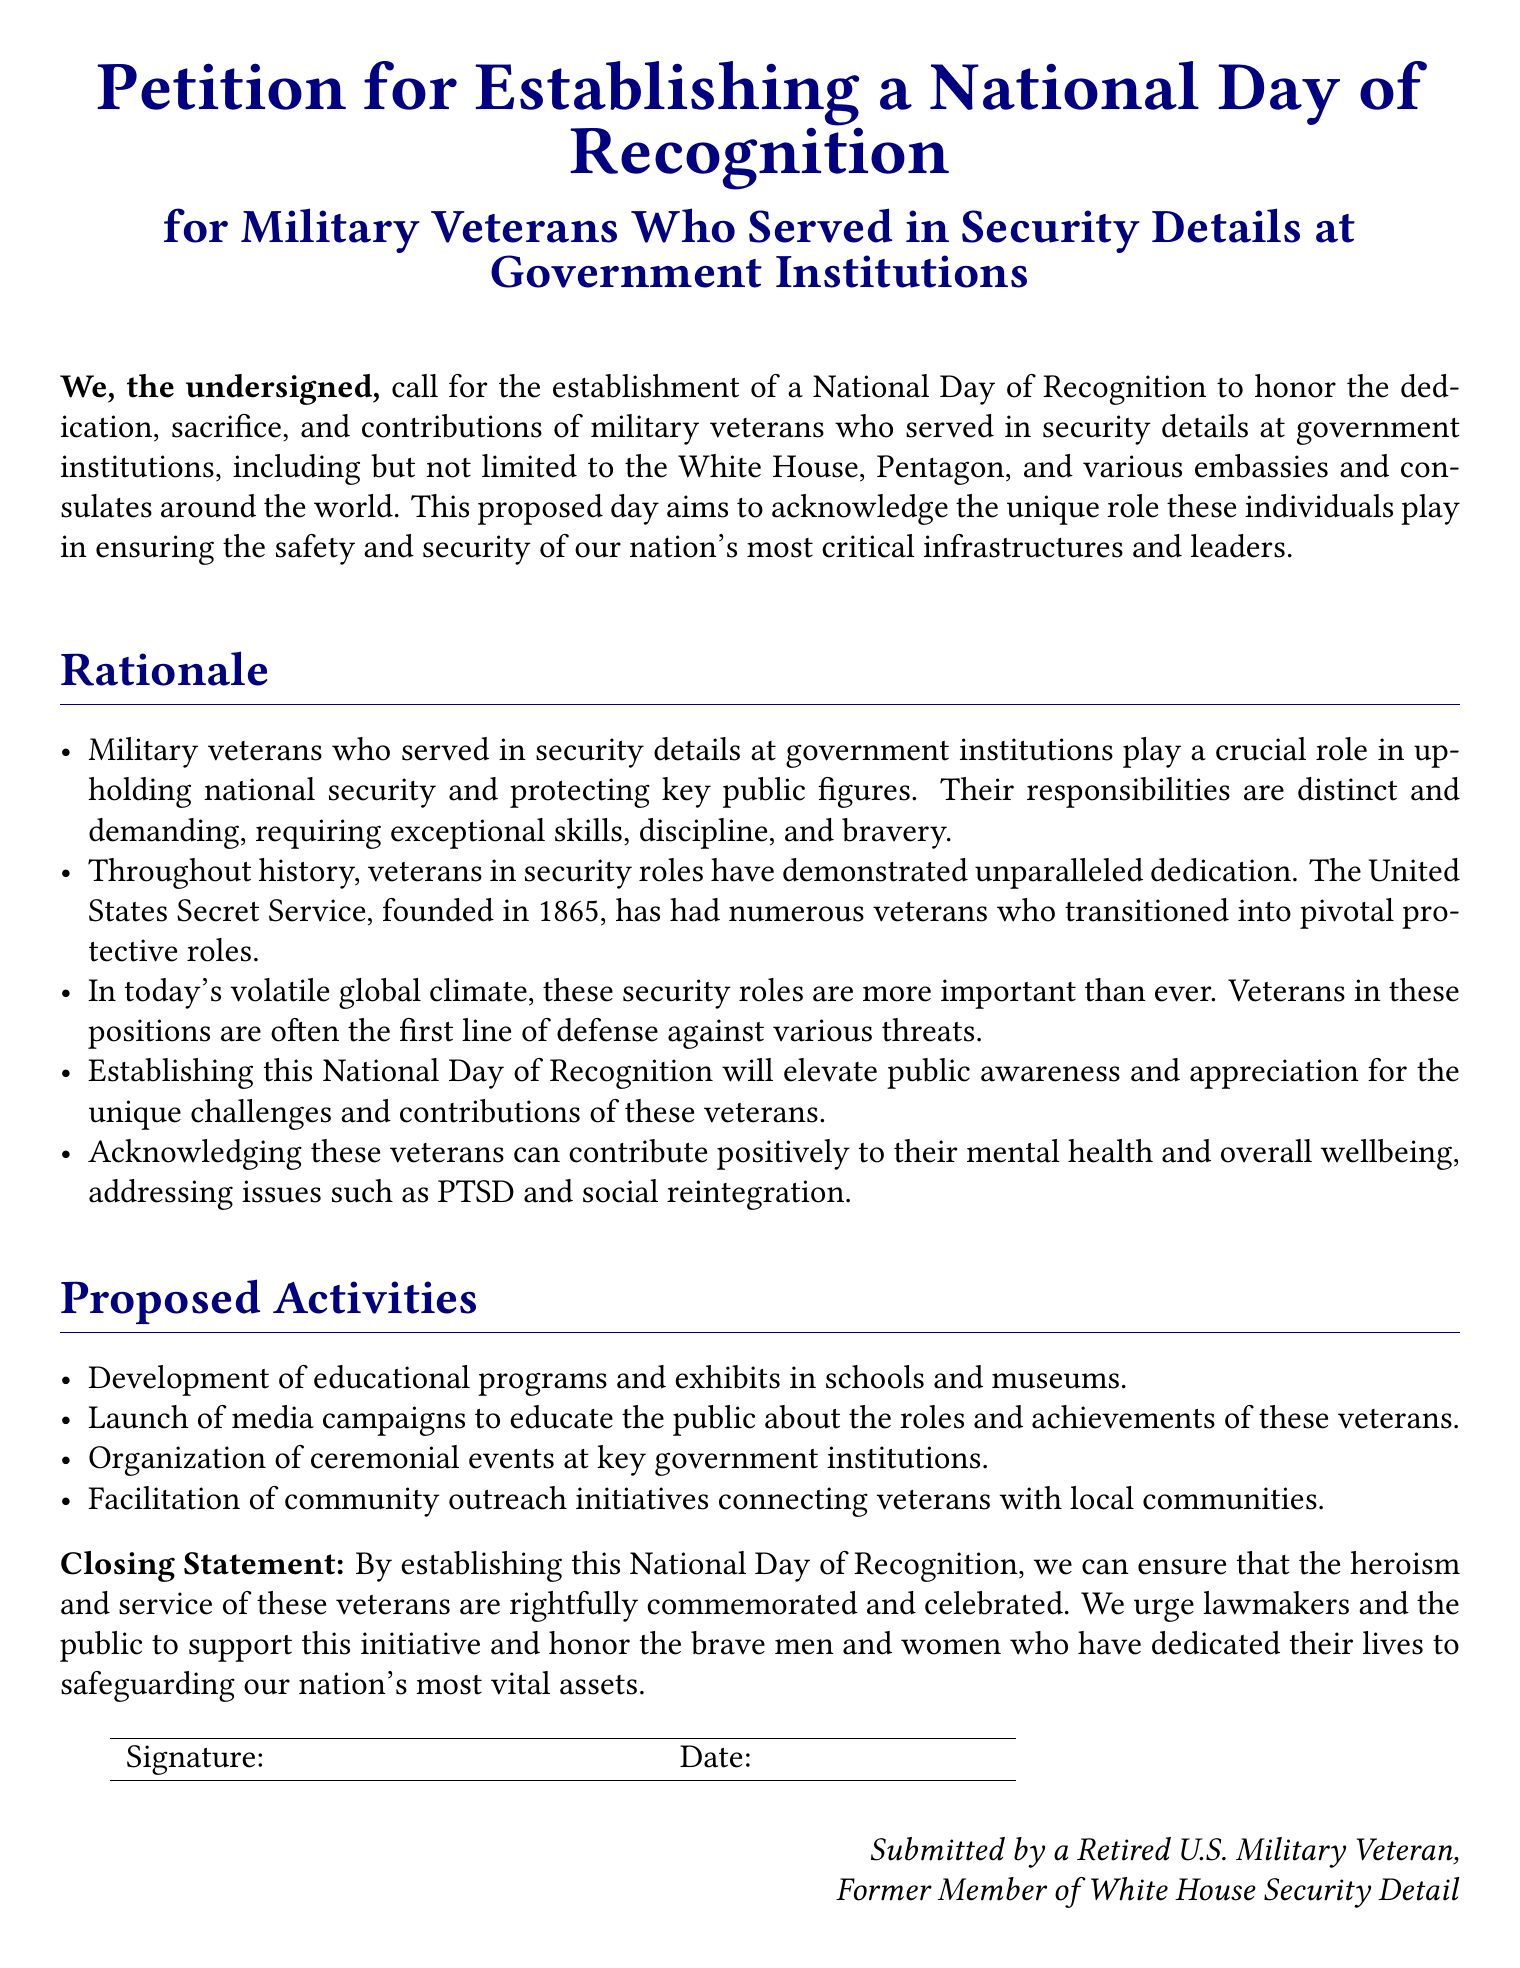What is the purpose of the petition? The purpose of the petition is to call for the establishment of a National Day of Recognition for military veterans who served in security details at government institutions.
Answer: National Day of Recognition Who are the veterans being recognized in the petition? The petition recognizes military veterans who served in security details at government institutions.
Answer: Military veterans What significant organization is mentioned in the rationale? The significant organization mentioned in the rationale is the United States Secret Service.
Answer: United States Secret Service What is one of the proposed activities in the petition? One of the proposed activities is the development of educational programs and exhibits in schools and museums.
Answer: Educational programs and exhibits What year was the United States Secret Service founded? The United States Secret Service was founded in 1865.
Answer: 1865 What is the underlying issue addressed by acknowledging these veterans? The acknowledgment of these veterans addresses issues such as PTSD and social reintegration.
Answer: PTSD and social reintegration What color is used for the title in the document? The color used for the title in the document is navy blue.
Answer: Navy blue What is the closing statement's call to action? The closing statement urges lawmakers and the public to support the initiative.
Answer: Support the initiative 